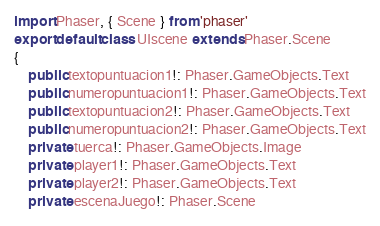Convert code to text. <code><loc_0><loc_0><loc_500><loc_500><_TypeScript_>import Phaser, { Scene } from 'phaser'
export default class UIscene extends Phaser.Scene
{
	public textopuntuacion1!: Phaser.GameObjects.Text
	public numeropuntuacion1!: Phaser.GameObjects.Text
	public textopuntuacion2!: Phaser.GameObjects.Text
	public numeropuntuacion2!: Phaser.GameObjects.Text
	private tuerca!: Phaser.GameObjects.Image
	private player1!: Phaser.GameObjects.Text
	private player2!: Phaser.GameObjects.Text
	private escenaJuego!: Phaser.Scene</code> 